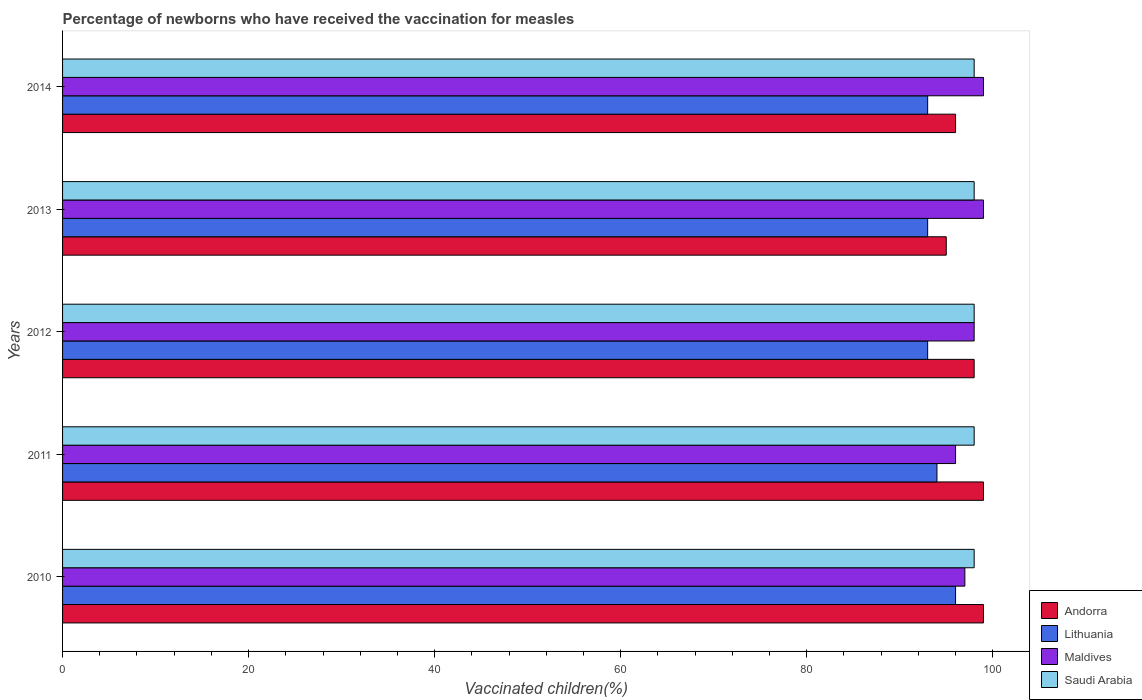How many different coloured bars are there?
Ensure brevity in your answer.  4. How many groups of bars are there?
Make the answer very short. 5. How many bars are there on the 4th tick from the bottom?
Provide a succinct answer. 4. What is the label of the 5th group of bars from the top?
Make the answer very short. 2010. What is the percentage of vaccinated children in Saudi Arabia in 2010?
Provide a succinct answer. 98. Across all years, what is the maximum percentage of vaccinated children in Lithuania?
Make the answer very short. 96. Across all years, what is the minimum percentage of vaccinated children in Maldives?
Your response must be concise. 96. In which year was the percentage of vaccinated children in Lithuania maximum?
Keep it short and to the point. 2010. What is the total percentage of vaccinated children in Saudi Arabia in the graph?
Offer a very short reply. 490. What is the difference between the percentage of vaccinated children in Lithuania in 2010 and that in 2014?
Ensure brevity in your answer.  3. What is the difference between the percentage of vaccinated children in Andorra in 2013 and the percentage of vaccinated children in Maldives in 2012?
Ensure brevity in your answer.  -3. In how many years, is the percentage of vaccinated children in Andorra greater than 20 %?
Offer a terse response. 5. What is the ratio of the percentage of vaccinated children in Andorra in 2011 to that in 2013?
Make the answer very short. 1.04. Is the difference between the percentage of vaccinated children in Andorra in 2010 and 2014 greater than the difference between the percentage of vaccinated children in Maldives in 2010 and 2014?
Your answer should be very brief. Yes. What is the difference between the highest and the second highest percentage of vaccinated children in Andorra?
Offer a very short reply. 0. Is it the case that in every year, the sum of the percentage of vaccinated children in Saudi Arabia and percentage of vaccinated children in Maldives is greater than the sum of percentage of vaccinated children in Andorra and percentage of vaccinated children in Lithuania?
Give a very brief answer. No. What does the 3rd bar from the top in 2014 represents?
Keep it short and to the point. Lithuania. What does the 1st bar from the bottom in 2012 represents?
Make the answer very short. Andorra. How many years are there in the graph?
Your answer should be compact. 5. Are the values on the major ticks of X-axis written in scientific E-notation?
Your answer should be compact. No. Does the graph contain any zero values?
Your answer should be compact. No. Where does the legend appear in the graph?
Give a very brief answer. Bottom right. How are the legend labels stacked?
Your answer should be very brief. Vertical. What is the title of the graph?
Your response must be concise. Percentage of newborns who have received the vaccination for measles. What is the label or title of the X-axis?
Give a very brief answer. Vaccinated children(%). What is the label or title of the Y-axis?
Your response must be concise. Years. What is the Vaccinated children(%) of Lithuania in 2010?
Keep it short and to the point. 96. What is the Vaccinated children(%) in Maldives in 2010?
Your response must be concise. 97. What is the Vaccinated children(%) in Saudi Arabia in 2010?
Ensure brevity in your answer.  98. What is the Vaccinated children(%) of Lithuania in 2011?
Your answer should be very brief. 94. What is the Vaccinated children(%) in Maldives in 2011?
Your response must be concise. 96. What is the Vaccinated children(%) in Saudi Arabia in 2011?
Your answer should be compact. 98. What is the Vaccinated children(%) of Andorra in 2012?
Your answer should be very brief. 98. What is the Vaccinated children(%) of Lithuania in 2012?
Keep it short and to the point. 93. What is the Vaccinated children(%) of Maldives in 2012?
Provide a succinct answer. 98. What is the Vaccinated children(%) in Saudi Arabia in 2012?
Your answer should be compact. 98. What is the Vaccinated children(%) in Lithuania in 2013?
Your answer should be very brief. 93. What is the Vaccinated children(%) in Andorra in 2014?
Keep it short and to the point. 96. What is the Vaccinated children(%) of Lithuania in 2014?
Provide a short and direct response. 93. What is the Vaccinated children(%) in Saudi Arabia in 2014?
Your answer should be very brief. 98. Across all years, what is the maximum Vaccinated children(%) of Lithuania?
Give a very brief answer. 96. Across all years, what is the maximum Vaccinated children(%) in Saudi Arabia?
Offer a very short reply. 98. Across all years, what is the minimum Vaccinated children(%) in Andorra?
Your answer should be compact. 95. Across all years, what is the minimum Vaccinated children(%) of Lithuania?
Keep it short and to the point. 93. Across all years, what is the minimum Vaccinated children(%) in Maldives?
Your answer should be compact. 96. What is the total Vaccinated children(%) of Andorra in the graph?
Your response must be concise. 487. What is the total Vaccinated children(%) in Lithuania in the graph?
Provide a short and direct response. 469. What is the total Vaccinated children(%) in Maldives in the graph?
Offer a very short reply. 489. What is the total Vaccinated children(%) in Saudi Arabia in the graph?
Ensure brevity in your answer.  490. What is the difference between the Vaccinated children(%) in Andorra in 2010 and that in 2011?
Give a very brief answer. 0. What is the difference between the Vaccinated children(%) of Maldives in 2010 and that in 2011?
Ensure brevity in your answer.  1. What is the difference between the Vaccinated children(%) of Andorra in 2010 and that in 2012?
Give a very brief answer. 1. What is the difference between the Vaccinated children(%) of Maldives in 2010 and that in 2012?
Keep it short and to the point. -1. What is the difference between the Vaccinated children(%) in Saudi Arabia in 2010 and that in 2012?
Provide a short and direct response. 0. What is the difference between the Vaccinated children(%) of Lithuania in 2010 and that in 2013?
Your response must be concise. 3. What is the difference between the Vaccinated children(%) in Andorra in 2010 and that in 2014?
Ensure brevity in your answer.  3. What is the difference between the Vaccinated children(%) of Maldives in 2010 and that in 2014?
Your answer should be compact. -2. What is the difference between the Vaccinated children(%) in Saudi Arabia in 2010 and that in 2014?
Provide a succinct answer. 0. What is the difference between the Vaccinated children(%) of Andorra in 2011 and that in 2012?
Offer a very short reply. 1. What is the difference between the Vaccinated children(%) of Lithuania in 2011 and that in 2012?
Your answer should be compact. 1. What is the difference between the Vaccinated children(%) in Saudi Arabia in 2011 and that in 2013?
Make the answer very short. 0. What is the difference between the Vaccinated children(%) in Lithuania in 2011 and that in 2014?
Your response must be concise. 1. What is the difference between the Vaccinated children(%) in Maldives in 2011 and that in 2014?
Make the answer very short. -3. What is the difference between the Vaccinated children(%) in Saudi Arabia in 2011 and that in 2014?
Provide a succinct answer. 0. What is the difference between the Vaccinated children(%) in Lithuania in 2012 and that in 2013?
Provide a short and direct response. 0. What is the difference between the Vaccinated children(%) of Saudi Arabia in 2012 and that in 2013?
Ensure brevity in your answer.  0. What is the difference between the Vaccinated children(%) of Andorra in 2012 and that in 2014?
Make the answer very short. 2. What is the difference between the Vaccinated children(%) of Maldives in 2013 and that in 2014?
Your answer should be compact. 0. What is the difference between the Vaccinated children(%) in Andorra in 2010 and the Vaccinated children(%) in Saudi Arabia in 2011?
Provide a short and direct response. 1. What is the difference between the Vaccinated children(%) of Lithuania in 2010 and the Vaccinated children(%) of Saudi Arabia in 2012?
Your answer should be very brief. -2. What is the difference between the Vaccinated children(%) of Andorra in 2010 and the Vaccinated children(%) of Lithuania in 2013?
Keep it short and to the point. 6. What is the difference between the Vaccinated children(%) of Lithuania in 2010 and the Vaccinated children(%) of Maldives in 2013?
Your response must be concise. -3. What is the difference between the Vaccinated children(%) of Lithuania in 2010 and the Vaccinated children(%) of Saudi Arabia in 2013?
Provide a succinct answer. -2. What is the difference between the Vaccinated children(%) in Andorra in 2010 and the Vaccinated children(%) in Maldives in 2014?
Keep it short and to the point. 0. What is the difference between the Vaccinated children(%) of Lithuania in 2010 and the Vaccinated children(%) of Maldives in 2014?
Ensure brevity in your answer.  -3. What is the difference between the Vaccinated children(%) of Lithuania in 2010 and the Vaccinated children(%) of Saudi Arabia in 2014?
Your answer should be very brief. -2. What is the difference between the Vaccinated children(%) in Lithuania in 2011 and the Vaccinated children(%) in Saudi Arabia in 2012?
Your response must be concise. -4. What is the difference between the Vaccinated children(%) in Andorra in 2011 and the Vaccinated children(%) in Lithuania in 2013?
Ensure brevity in your answer.  6. What is the difference between the Vaccinated children(%) in Andorra in 2011 and the Vaccinated children(%) in Saudi Arabia in 2013?
Make the answer very short. 1. What is the difference between the Vaccinated children(%) of Lithuania in 2011 and the Vaccinated children(%) of Saudi Arabia in 2013?
Provide a succinct answer. -4. What is the difference between the Vaccinated children(%) in Maldives in 2011 and the Vaccinated children(%) in Saudi Arabia in 2013?
Provide a short and direct response. -2. What is the difference between the Vaccinated children(%) in Andorra in 2011 and the Vaccinated children(%) in Maldives in 2014?
Keep it short and to the point. 0. What is the difference between the Vaccinated children(%) in Andorra in 2011 and the Vaccinated children(%) in Saudi Arabia in 2014?
Provide a short and direct response. 1. What is the difference between the Vaccinated children(%) of Lithuania in 2011 and the Vaccinated children(%) of Maldives in 2014?
Your answer should be very brief. -5. What is the difference between the Vaccinated children(%) of Lithuania in 2011 and the Vaccinated children(%) of Saudi Arabia in 2014?
Ensure brevity in your answer.  -4. What is the difference between the Vaccinated children(%) of Andorra in 2012 and the Vaccinated children(%) of Lithuania in 2013?
Provide a succinct answer. 5. What is the difference between the Vaccinated children(%) in Andorra in 2012 and the Vaccinated children(%) in Saudi Arabia in 2013?
Provide a succinct answer. 0. What is the difference between the Vaccinated children(%) of Lithuania in 2012 and the Vaccinated children(%) of Saudi Arabia in 2013?
Provide a short and direct response. -5. What is the difference between the Vaccinated children(%) in Maldives in 2012 and the Vaccinated children(%) in Saudi Arabia in 2013?
Your answer should be very brief. 0. What is the difference between the Vaccinated children(%) of Andorra in 2012 and the Vaccinated children(%) of Saudi Arabia in 2014?
Offer a very short reply. 0. What is the difference between the Vaccinated children(%) in Lithuania in 2012 and the Vaccinated children(%) in Maldives in 2014?
Your answer should be compact. -6. What is the difference between the Vaccinated children(%) of Andorra in 2013 and the Vaccinated children(%) of Maldives in 2014?
Give a very brief answer. -4. What is the difference between the Vaccinated children(%) in Lithuania in 2013 and the Vaccinated children(%) in Saudi Arabia in 2014?
Keep it short and to the point. -5. What is the difference between the Vaccinated children(%) of Maldives in 2013 and the Vaccinated children(%) of Saudi Arabia in 2014?
Keep it short and to the point. 1. What is the average Vaccinated children(%) in Andorra per year?
Give a very brief answer. 97.4. What is the average Vaccinated children(%) of Lithuania per year?
Your answer should be compact. 93.8. What is the average Vaccinated children(%) of Maldives per year?
Ensure brevity in your answer.  97.8. In the year 2010, what is the difference between the Vaccinated children(%) of Andorra and Vaccinated children(%) of Maldives?
Give a very brief answer. 2. In the year 2010, what is the difference between the Vaccinated children(%) of Andorra and Vaccinated children(%) of Saudi Arabia?
Your response must be concise. 1. In the year 2010, what is the difference between the Vaccinated children(%) in Lithuania and Vaccinated children(%) in Maldives?
Provide a succinct answer. -1. In the year 2010, what is the difference between the Vaccinated children(%) in Lithuania and Vaccinated children(%) in Saudi Arabia?
Offer a very short reply. -2. In the year 2010, what is the difference between the Vaccinated children(%) of Maldives and Vaccinated children(%) of Saudi Arabia?
Your answer should be compact. -1. In the year 2011, what is the difference between the Vaccinated children(%) of Andorra and Vaccinated children(%) of Maldives?
Ensure brevity in your answer.  3. In the year 2011, what is the difference between the Vaccinated children(%) of Lithuania and Vaccinated children(%) of Saudi Arabia?
Your answer should be compact. -4. In the year 2011, what is the difference between the Vaccinated children(%) in Maldives and Vaccinated children(%) in Saudi Arabia?
Your response must be concise. -2. In the year 2012, what is the difference between the Vaccinated children(%) in Andorra and Vaccinated children(%) in Maldives?
Provide a short and direct response. 0. In the year 2012, what is the difference between the Vaccinated children(%) in Andorra and Vaccinated children(%) in Saudi Arabia?
Make the answer very short. 0. In the year 2012, what is the difference between the Vaccinated children(%) in Lithuania and Vaccinated children(%) in Maldives?
Offer a terse response. -5. In the year 2012, what is the difference between the Vaccinated children(%) in Lithuania and Vaccinated children(%) in Saudi Arabia?
Your answer should be compact. -5. In the year 2013, what is the difference between the Vaccinated children(%) in Andorra and Vaccinated children(%) in Lithuania?
Your answer should be very brief. 2. In the year 2013, what is the difference between the Vaccinated children(%) in Andorra and Vaccinated children(%) in Saudi Arabia?
Your answer should be very brief. -3. In the year 2014, what is the difference between the Vaccinated children(%) of Lithuania and Vaccinated children(%) of Maldives?
Ensure brevity in your answer.  -6. What is the ratio of the Vaccinated children(%) in Andorra in 2010 to that in 2011?
Your response must be concise. 1. What is the ratio of the Vaccinated children(%) in Lithuania in 2010 to that in 2011?
Offer a very short reply. 1.02. What is the ratio of the Vaccinated children(%) in Maldives in 2010 to that in 2011?
Your response must be concise. 1.01. What is the ratio of the Vaccinated children(%) in Saudi Arabia in 2010 to that in 2011?
Give a very brief answer. 1. What is the ratio of the Vaccinated children(%) in Andorra in 2010 to that in 2012?
Ensure brevity in your answer.  1.01. What is the ratio of the Vaccinated children(%) in Lithuania in 2010 to that in 2012?
Your answer should be very brief. 1.03. What is the ratio of the Vaccinated children(%) in Maldives in 2010 to that in 2012?
Provide a succinct answer. 0.99. What is the ratio of the Vaccinated children(%) in Andorra in 2010 to that in 2013?
Give a very brief answer. 1.04. What is the ratio of the Vaccinated children(%) of Lithuania in 2010 to that in 2013?
Your answer should be very brief. 1.03. What is the ratio of the Vaccinated children(%) in Maldives in 2010 to that in 2013?
Your response must be concise. 0.98. What is the ratio of the Vaccinated children(%) of Saudi Arabia in 2010 to that in 2013?
Provide a succinct answer. 1. What is the ratio of the Vaccinated children(%) of Andorra in 2010 to that in 2014?
Give a very brief answer. 1.03. What is the ratio of the Vaccinated children(%) of Lithuania in 2010 to that in 2014?
Your answer should be very brief. 1.03. What is the ratio of the Vaccinated children(%) in Maldives in 2010 to that in 2014?
Provide a succinct answer. 0.98. What is the ratio of the Vaccinated children(%) of Saudi Arabia in 2010 to that in 2014?
Ensure brevity in your answer.  1. What is the ratio of the Vaccinated children(%) of Andorra in 2011 to that in 2012?
Your answer should be compact. 1.01. What is the ratio of the Vaccinated children(%) of Lithuania in 2011 to that in 2012?
Your answer should be very brief. 1.01. What is the ratio of the Vaccinated children(%) in Maldives in 2011 to that in 2012?
Ensure brevity in your answer.  0.98. What is the ratio of the Vaccinated children(%) of Andorra in 2011 to that in 2013?
Keep it short and to the point. 1.04. What is the ratio of the Vaccinated children(%) of Lithuania in 2011 to that in 2013?
Make the answer very short. 1.01. What is the ratio of the Vaccinated children(%) in Maldives in 2011 to that in 2013?
Provide a succinct answer. 0.97. What is the ratio of the Vaccinated children(%) of Saudi Arabia in 2011 to that in 2013?
Provide a succinct answer. 1. What is the ratio of the Vaccinated children(%) of Andorra in 2011 to that in 2014?
Your answer should be compact. 1.03. What is the ratio of the Vaccinated children(%) of Lithuania in 2011 to that in 2014?
Ensure brevity in your answer.  1.01. What is the ratio of the Vaccinated children(%) in Maldives in 2011 to that in 2014?
Give a very brief answer. 0.97. What is the ratio of the Vaccinated children(%) of Saudi Arabia in 2011 to that in 2014?
Keep it short and to the point. 1. What is the ratio of the Vaccinated children(%) in Andorra in 2012 to that in 2013?
Provide a succinct answer. 1.03. What is the ratio of the Vaccinated children(%) of Lithuania in 2012 to that in 2013?
Offer a terse response. 1. What is the ratio of the Vaccinated children(%) of Maldives in 2012 to that in 2013?
Your response must be concise. 0.99. What is the ratio of the Vaccinated children(%) of Saudi Arabia in 2012 to that in 2013?
Offer a terse response. 1. What is the ratio of the Vaccinated children(%) of Andorra in 2012 to that in 2014?
Make the answer very short. 1.02. What is the ratio of the Vaccinated children(%) in Lithuania in 2012 to that in 2014?
Keep it short and to the point. 1. What is the ratio of the Vaccinated children(%) of Andorra in 2013 to that in 2014?
Provide a short and direct response. 0.99. What is the ratio of the Vaccinated children(%) of Lithuania in 2013 to that in 2014?
Keep it short and to the point. 1. What is the ratio of the Vaccinated children(%) of Maldives in 2013 to that in 2014?
Ensure brevity in your answer.  1. What is the difference between the highest and the second highest Vaccinated children(%) of Andorra?
Ensure brevity in your answer.  0. What is the difference between the highest and the second highest Vaccinated children(%) of Lithuania?
Offer a terse response. 2. What is the difference between the highest and the second highest Vaccinated children(%) of Saudi Arabia?
Offer a terse response. 0. What is the difference between the highest and the lowest Vaccinated children(%) in Lithuania?
Provide a succinct answer. 3. What is the difference between the highest and the lowest Vaccinated children(%) of Maldives?
Offer a terse response. 3. What is the difference between the highest and the lowest Vaccinated children(%) in Saudi Arabia?
Your response must be concise. 0. 